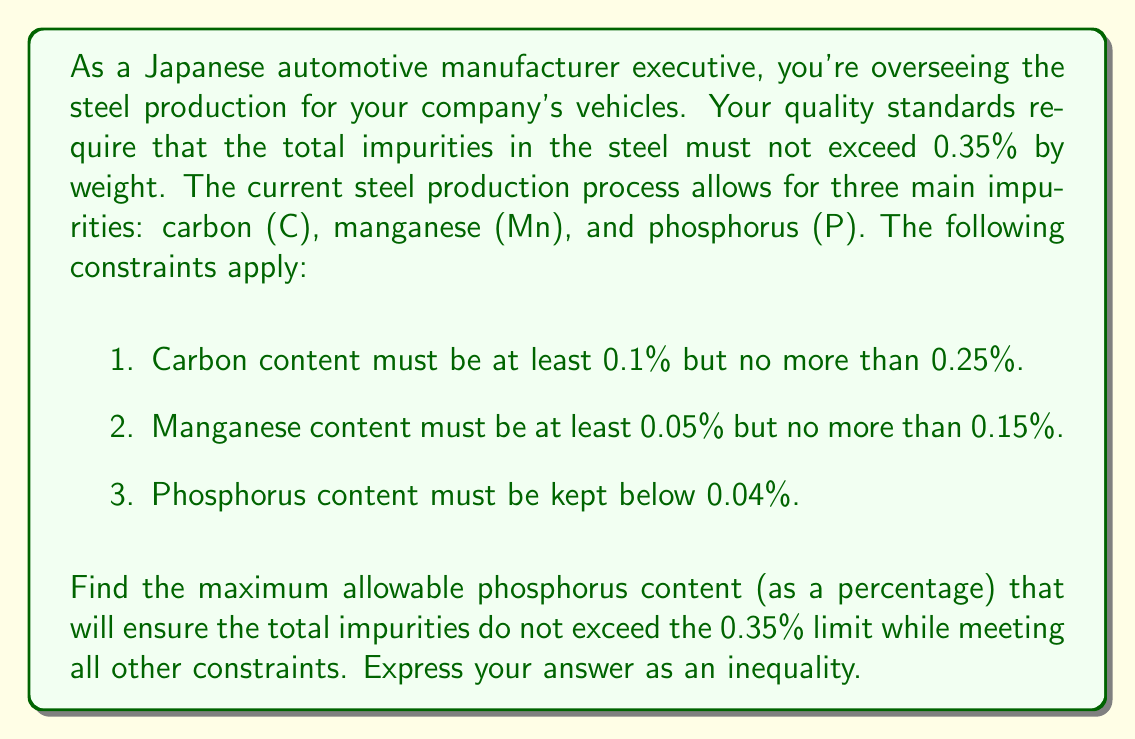Can you solve this math problem? Let's approach this step-by-step:

1. Define variables:
   Let $x$ be the percentage of phosphorus in the steel.

2. Set up the inequality:
   Total impurities $\leq$ 0.35%
   $$(C_{max} + Mn_{max} + x) \leq 0.35$$

3. Substitute the maximum values for carbon and manganese:
   $$(0.25 + 0.15 + x) \leq 0.35$$

4. Simplify:
   $$0.40 + x \leq 0.35$$

5. Subtract 0.40 from both sides:
   $$x \leq 0.35 - 0.40 = -0.05$$

6. However, we know that $x$ cannot be negative as it represents a percentage. Also, the problem states that phosphorus content must be below 0.04%.

7. Therefore, we need to find the minimum of these two upper bounds:
   $$x \leq \min(-0.05, 0.04) = 0.04$$

8. Express the final inequality:
   $$0 \leq x < 0.04$$

This inequality satisfies all the given constraints while maximizing the allowable phosphorus content.
Answer: $$0 \leq x < 0.04$$
where $x$ represents the phosphorus content as a percentage. 